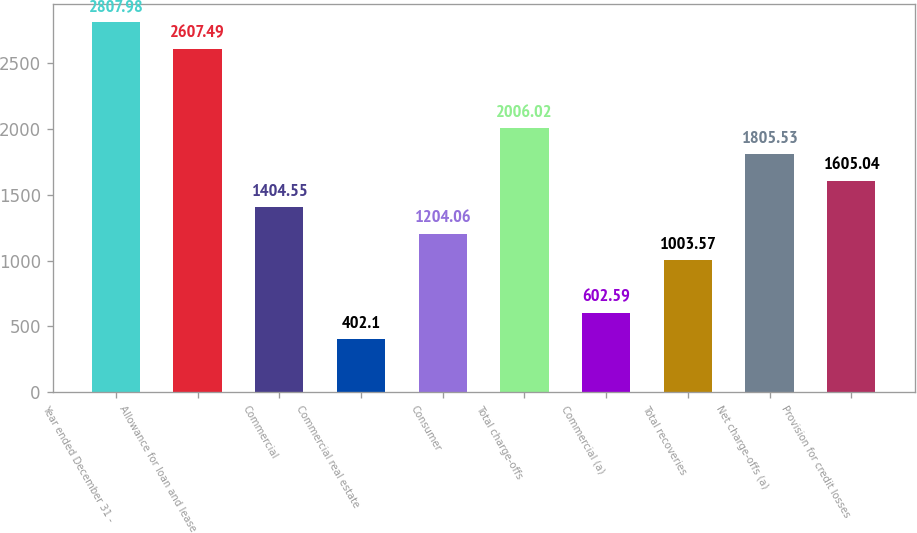Convert chart. <chart><loc_0><loc_0><loc_500><loc_500><bar_chart><fcel>Year ended December 31 -<fcel>Allowance for loan and lease<fcel>Commercial<fcel>Commercial real estate<fcel>Consumer<fcel>Total charge-offs<fcel>Commercial (a)<fcel>Total recoveries<fcel>Net charge-offs (a)<fcel>Provision for credit losses<nl><fcel>2807.98<fcel>2607.49<fcel>1404.55<fcel>402.1<fcel>1204.06<fcel>2006.02<fcel>602.59<fcel>1003.57<fcel>1805.53<fcel>1605.04<nl></chart> 